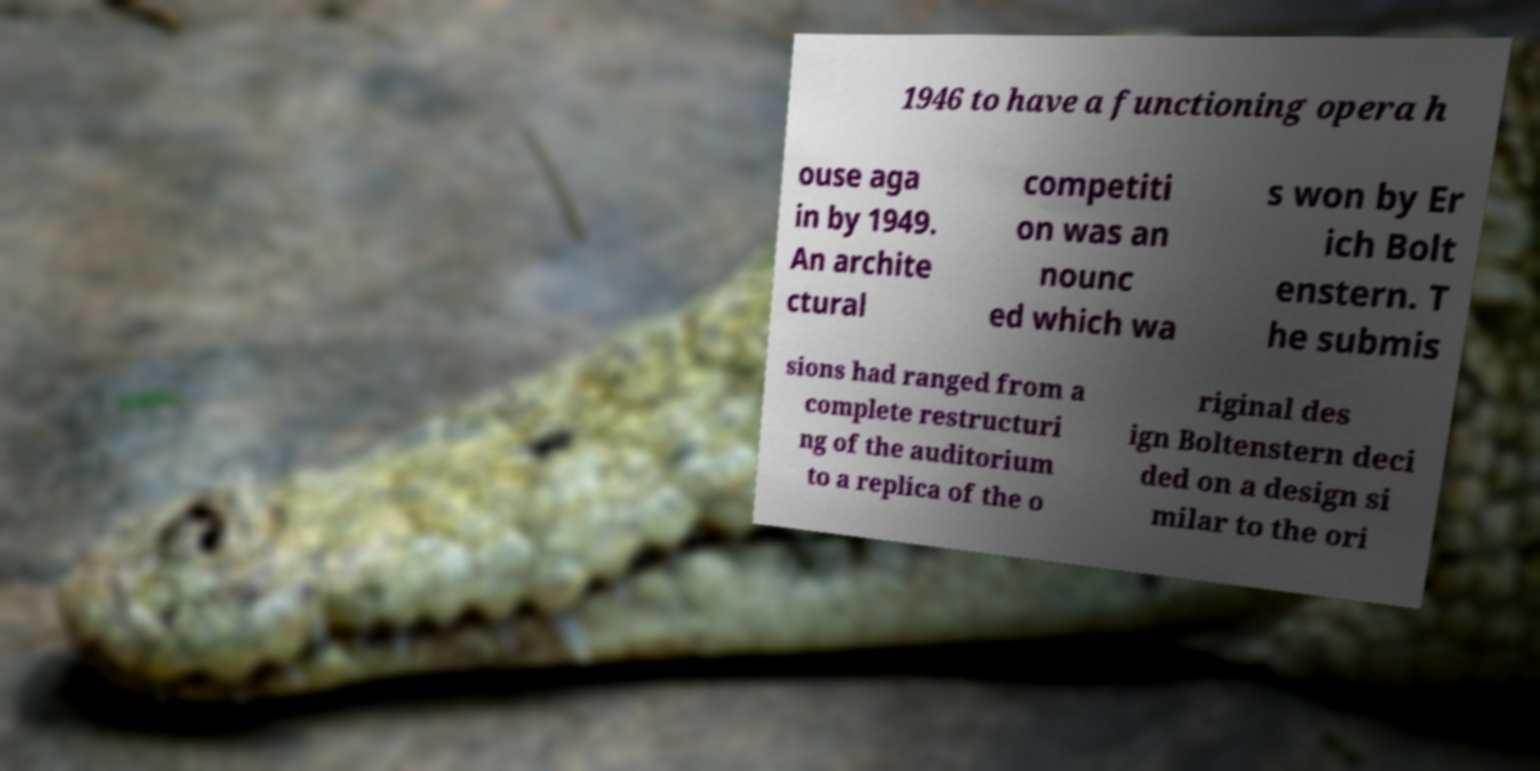Could you extract and type out the text from this image? 1946 to have a functioning opera h ouse aga in by 1949. An archite ctural competiti on was an nounc ed which wa s won by Er ich Bolt enstern. T he submis sions had ranged from a complete restructuri ng of the auditorium to a replica of the o riginal des ign Boltenstern deci ded on a design si milar to the ori 